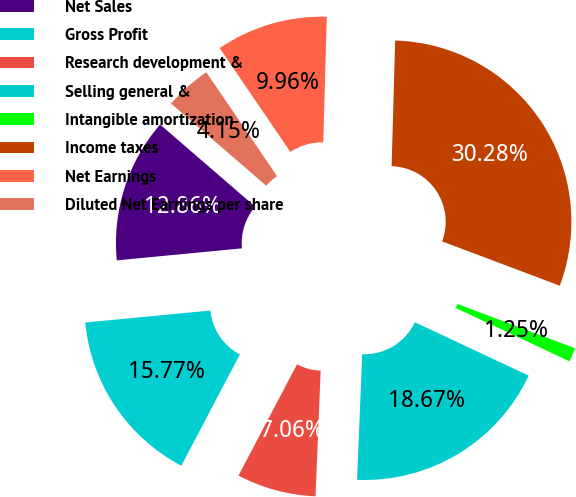Convert chart to OTSL. <chart><loc_0><loc_0><loc_500><loc_500><pie_chart><fcel>Net Sales<fcel>Gross Profit<fcel>Research development &<fcel>Selling general &<fcel>Intangible amortization<fcel>Income taxes<fcel>Net Earnings<fcel>Diluted Net Earnings per share<nl><fcel>12.86%<fcel>15.77%<fcel>7.06%<fcel>18.67%<fcel>1.25%<fcel>30.28%<fcel>9.96%<fcel>4.15%<nl></chart> 